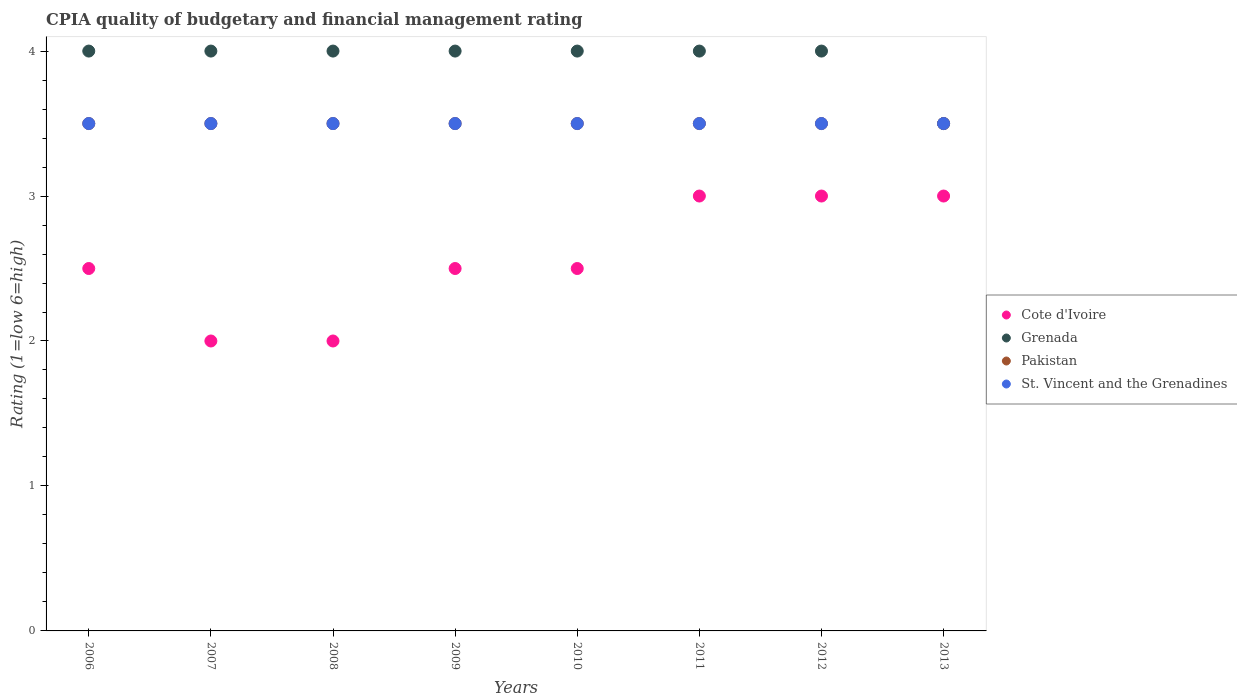What is the CPIA rating in Grenada in 2007?
Offer a very short reply. 4. In which year was the CPIA rating in St. Vincent and the Grenadines minimum?
Offer a very short reply. 2006. What is the total CPIA rating in Grenada in the graph?
Your response must be concise. 31.5. In the year 2006, what is the difference between the CPIA rating in St. Vincent and the Grenadines and CPIA rating in Pakistan?
Make the answer very short. 0. What is the ratio of the CPIA rating in Pakistan in 2008 to that in 2012?
Your response must be concise. 1. Is the CPIA rating in Grenada in 2006 less than that in 2007?
Ensure brevity in your answer.  No. What is the difference between the highest and the lowest CPIA rating in Grenada?
Give a very brief answer. 0.5. In how many years, is the CPIA rating in Cote d'Ivoire greater than the average CPIA rating in Cote d'Ivoire taken over all years?
Provide a succinct answer. 3. Is it the case that in every year, the sum of the CPIA rating in Cote d'Ivoire and CPIA rating in St. Vincent and the Grenadines  is greater than the sum of CPIA rating in Grenada and CPIA rating in Pakistan?
Provide a succinct answer. No. Is it the case that in every year, the sum of the CPIA rating in Grenada and CPIA rating in Cote d'Ivoire  is greater than the CPIA rating in St. Vincent and the Grenadines?
Your answer should be very brief. Yes. Does the CPIA rating in St. Vincent and the Grenadines monotonically increase over the years?
Your response must be concise. No. Is the CPIA rating in Pakistan strictly greater than the CPIA rating in St. Vincent and the Grenadines over the years?
Offer a very short reply. No. Is the CPIA rating in Grenada strictly less than the CPIA rating in Pakistan over the years?
Ensure brevity in your answer.  No. What is the difference between two consecutive major ticks on the Y-axis?
Provide a succinct answer. 1. Does the graph contain any zero values?
Offer a terse response. No. Does the graph contain grids?
Provide a short and direct response. No. How are the legend labels stacked?
Keep it short and to the point. Vertical. What is the title of the graph?
Your response must be concise. CPIA quality of budgetary and financial management rating. Does "Pacific island small states" appear as one of the legend labels in the graph?
Keep it short and to the point. No. What is the Rating (1=low 6=high) of Pakistan in 2006?
Your answer should be compact. 3.5. What is the Rating (1=low 6=high) in St. Vincent and the Grenadines in 2006?
Ensure brevity in your answer.  3.5. What is the Rating (1=low 6=high) in Grenada in 2007?
Keep it short and to the point. 4. What is the Rating (1=low 6=high) of St. Vincent and the Grenadines in 2007?
Make the answer very short. 3.5. What is the Rating (1=low 6=high) of Cote d'Ivoire in 2008?
Offer a terse response. 2. What is the Rating (1=low 6=high) in Grenada in 2008?
Give a very brief answer. 4. What is the Rating (1=low 6=high) of St. Vincent and the Grenadines in 2008?
Your answer should be very brief. 3.5. What is the Rating (1=low 6=high) in Pakistan in 2009?
Your answer should be compact. 3.5. What is the Rating (1=low 6=high) in St. Vincent and the Grenadines in 2009?
Give a very brief answer. 3.5. What is the Rating (1=low 6=high) of St. Vincent and the Grenadines in 2010?
Provide a succinct answer. 3.5. What is the Rating (1=low 6=high) in Grenada in 2011?
Your answer should be compact. 4. What is the Rating (1=low 6=high) in Pakistan in 2011?
Give a very brief answer. 3.5. What is the Rating (1=low 6=high) in Pakistan in 2012?
Make the answer very short. 3.5. What is the Rating (1=low 6=high) in Cote d'Ivoire in 2013?
Offer a terse response. 3. What is the Rating (1=low 6=high) in Grenada in 2013?
Give a very brief answer. 3.5. What is the Rating (1=low 6=high) of Pakistan in 2013?
Provide a short and direct response. 3.5. Across all years, what is the maximum Rating (1=low 6=high) of Cote d'Ivoire?
Offer a terse response. 3. Across all years, what is the maximum Rating (1=low 6=high) in Grenada?
Make the answer very short. 4. Across all years, what is the maximum Rating (1=low 6=high) of Pakistan?
Give a very brief answer. 3.5. Across all years, what is the maximum Rating (1=low 6=high) in St. Vincent and the Grenadines?
Your answer should be compact. 3.5. Across all years, what is the minimum Rating (1=low 6=high) of Grenada?
Offer a terse response. 3.5. Across all years, what is the minimum Rating (1=low 6=high) of Pakistan?
Your response must be concise. 3.5. Across all years, what is the minimum Rating (1=low 6=high) in St. Vincent and the Grenadines?
Provide a short and direct response. 3.5. What is the total Rating (1=low 6=high) of Grenada in the graph?
Offer a terse response. 31.5. What is the total Rating (1=low 6=high) in Pakistan in the graph?
Make the answer very short. 28. What is the difference between the Rating (1=low 6=high) of Grenada in 2006 and that in 2007?
Provide a short and direct response. 0. What is the difference between the Rating (1=low 6=high) in Pakistan in 2006 and that in 2007?
Provide a short and direct response. 0. What is the difference between the Rating (1=low 6=high) of Cote d'Ivoire in 2006 and that in 2008?
Keep it short and to the point. 0.5. What is the difference between the Rating (1=low 6=high) in St. Vincent and the Grenadines in 2006 and that in 2008?
Make the answer very short. 0. What is the difference between the Rating (1=low 6=high) in Cote d'Ivoire in 2006 and that in 2010?
Your answer should be compact. 0. What is the difference between the Rating (1=low 6=high) of Grenada in 2006 and that in 2010?
Your answer should be compact. 0. What is the difference between the Rating (1=low 6=high) of Grenada in 2006 and that in 2011?
Offer a very short reply. 0. What is the difference between the Rating (1=low 6=high) in Cote d'Ivoire in 2006 and that in 2012?
Offer a very short reply. -0.5. What is the difference between the Rating (1=low 6=high) of Cote d'Ivoire in 2006 and that in 2013?
Keep it short and to the point. -0.5. What is the difference between the Rating (1=low 6=high) in Pakistan in 2006 and that in 2013?
Keep it short and to the point. 0. What is the difference between the Rating (1=low 6=high) of St. Vincent and the Grenadines in 2006 and that in 2013?
Your answer should be compact. 0. What is the difference between the Rating (1=low 6=high) of Grenada in 2007 and that in 2008?
Your answer should be compact. 0. What is the difference between the Rating (1=low 6=high) in Pakistan in 2007 and that in 2008?
Offer a terse response. 0. What is the difference between the Rating (1=low 6=high) of St. Vincent and the Grenadines in 2007 and that in 2008?
Offer a very short reply. 0. What is the difference between the Rating (1=low 6=high) in Grenada in 2007 and that in 2009?
Your answer should be compact. 0. What is the difference between the Rating (1=low 6=high) in Pakistan in 2007 and that in 2009?
Your answer should be very brief. 0. What is the difference between the Rating (1=low 6=high) in St. Vincent and the Grenadines in 2007 and that in 2009?
Your answer should be compact. 0. What is the difference between the Rating (1=low 6=high) in Cote d'Ivoire in 2007 and that in 2010?
Offer a terse response. -0.5. What is the difference between the Rating (1=low 6=high) in Grenada in 2007 and that in 2010?
Provide a succinct answer. 0. What is the difference between the Rating (1=low 6=high) in St. Vincent and the Grenadines in 2007 and that in 2010?
Keep it short and to the point. 0. What is the difference between the Rating (1=low 6=high) in Cote d'Ivoire in 2007 and that in 2011?
Keep it short and to the point. -1. What is the difference between the Rating (1=low 6=high) of St. Vincent and the Grenadines in 2007 and that in 2011?
Give a very brief answer. 0. What is the difference between the Rating (1=low 6=high) in Grenada in 2007 and that in 2012?
Give a very brief answer. 0. What is the difference between the Rating (1=low 6=high) of Cote d'Ivoire in 2007 and that in 2013?
Provide a short and direct response. -1. What is the difference between the Rating (1=low 6=high) of Grenada in 2007 and that in 2013?
Provide a succinct answer. 0.5. What is the difference between the Rating (1=low 6=high) in Pakistan in 2007 and that in 2013?
Provide a short and direct response. 0. What is the difference between the Rating (1=low 6=high) of St. Vincent and the Grenadines in 2007 and that in 2013?
Make the answer very short. 0. What is the difference between the Rating (1=low 6=high) in St. Vincent and the Grenadines in 2008 and that in 2009?
Your answer should be very brief. 0. What is the difference between the Rating (1=low 6=high) of Grenada in 2008 and that in 2010?
Ensure brevity in your answer.  0. What is the difference between the Rating (1=low 6=high) in Pakistan in 2008 and that in 2010?
Your answer should be compact. 0. What is the difference between the Rating (1=low 6=high) in St. Vincent and the Grenadines in 2008 and that in 2010?
Your response must be concise. 0. What is the difference between the Rating (1=low 6=high) of Cote d'Ivoire in 2008 and that in 2011?
Offer a terse response. -1. What is the difference between the Rating (1=low 6=high) of Grenada in 2008 and that in 2011?
Provide a short and direct response. 0. What is the difference between the Rating (1=low 6=high) in Pakistan in 2008 and that in 2011?
Your answer should be very brief. 0. What is the difference between the Rating (1=low 6=high) of St. Vincent and the Grenadines in 2008 and that in 2011?
Your answer should be very brief. 0. What is the difference between the Rating (1=low 6=high) of Cote d'Ivoire in 2008 and that in 2013?
Offer a terse response. -1. What is the difference between the Rating (1=low 6=high) of Grenada in 2008 and that in 2013?
Provide a short and direct response. 0.5. What is the difference between the Rating (1=low 6=high) of St. Vincent and the Grenadines in 2008 and that in 2013?
Your answer should be compact. 0. What is the difference between the Rating (1=low 6=high) of Cote d'Ivoire in 2009 and that in 2010?
Keep it short and to the point. 0. What is the difference between the Rating (1=low 6=high) of St. Vincent and the Grenadines in 2009 and that in 2010?
Your answer should be compact. 0. What is the difference between the Rating (1=low 6=high) of Cote d'Ivoire in 2009 and that in 2011?
Offer a terse response. -0.5. What is the difference between the Rating (1=low 6=high) of Grenada in 2009 and that in 2011?
Your response must be concise. 0. What is the difference between the Rating (1=low 6=high) in Pakistan in 2009 and that in 2011?
Ensure brevity in your answer.  0. What is the difference between the Rating (1=low 6=high) in Cote d'Ivoire in 2009 and that in 2012?
Keep it short and to the point. -0.5. What is the difference between the Rating (1=low 6=high) of Grenada in 2009 and that in 2012?
Keep it short and to the point. 0. What is the difference between the Rating (1=low 6=high) in St. Vincent and the Grenadines in 2009 and that in 2012?
Keep it short and to the point. 0. What is the difference between the Rating (1=low 6=high) of Cote d'Ivoire in 2009 and that in 2013?
Give a very brief answer. -0.5. What is the difference between the Rating (1=low 6=high) in Grenada in 2009 and that in 2013?
Offer a very short reply. 0.5. What is the difference between the Rating (1=low 6=high) of Pakistan in 2009 and that in 2013?
Provide a short and direct response. 0. What is the difference between the Rating (1=low 6=high) of Pakistan in 2010 and that in 2011?
Your response must be concise. 0. What is the difference between the Rating (1=low 6=high) in Grenada in 2010 and that in 2012?
Give a very brief answer. 0. What is the difference between the Rating (1=low 6=high) in Grenada in 2010 and that in 2013?
Provide a succinct answer. 0.5. What is the difference between the Rating (1=low 6=high) in St. Vincent and the Grenadines in 2010 and that in 2013?
Provide a succinct answer. 0. What is the difference between the Rating (1=low 6=high) in Grenada in 2011 and that in 2012?
Your answer should be compact. 0. What is the difference between the Rating (1=low 6=high) of Cote d'Ivoire in 2011 and that in 2013?
Provide a succinct answer. 0. What is the difference between the Rating (1=low 6=high) in Grenada in 2011 and that in 2013?
Offer a very short reply. 0.5. What is the difference between the Rating (1=low 6=high) in Pakistan in 2011 and that in 2013?
Your response must be concise. 0. What is the difference between the Rating (1=low 6=high) of St. Vincent and the Grenadines in 2011 and that in 2013?
Give a very brief answer. 0. What is the difference between the Rating (1=low 6=high) of Cote d'Ivoire in 2012 and that in 2013?
Provide a succinct answer. 0. What is the difference between the Rating (1=low 6=high) of St. Vincent and the Grenadines in 2012 and that in 2013?
Your answer should be very brief. 0. What is the difference between the Rating (1=low 6=high) of Cote d'Ivoire in 2006 and the Rating (1=low 6=high) of Grenada in 2007?
Your answer should be compact. -1.5. What is the difference between the Rating (1=low 6=high) of Cote d'Ivoire in 2006 and the Rating (1=low 6=high) of Pakistan in 2007?
Provide a short and direct response. -1. What is the difference between the Rating (1=low 6=high) of Cote d'Ivoire in 2006 and the Rating (1=low 6=high) of St. Vincent and the Grenadines in 2007?
Ensure brevity in your answer.  -1. What is the difference between the Rating (1=low 6=high) of Grenada in 2006 and the Rating (1=low 6=high) of Pakistan in 2007?
Make the answer very short. 0.5. What is the difference between the Rating (1=low 6=high) of Grenada in 2006 and the Rating (1=low 6=high) of St. Vincent and the Grenadines in 2007?
Keep it short and to the point. 0.5. What is the difference between the Rating (1=low 6=high) in Cote d'Ivoire in 2006 and the Rating (1=low 6=high) in Pakistan in 2008?
Keep it short and to the point. -1. What is the difference between the Rating (1=low 6=high) in Pakistan in 2006 and the Rating (1=low 6=high) in St. Vincent and the Grenadines in 2008?
Make the answer very short. 0. What is the difference between the Rating (1=low 6=high) of Cote d'Ivoire in 2006 and the Rating (1=low 6=high) of Grenada in 2009?
Your answer should be very brief. -1.5. What is the difference between the Rating (1=low 6=high) in Cote d'Ivoire in 2006 and the Rating (1=low 6=high) in Pakistan in 2009?
Keep it short and to the point. -1. What is the difference between the Rating (1=low 6=high) of Cote d'Ivoire in 2006 and the Rating (1=low 6=high) of St. Vincent and the Grenadines in 2009?
Make the answer very short. -1. What is the difference between the Rating (1=low 6=high) of Grenada in 2006 and the Rating (1=low 6=high) of Pakistan in 2009?
Provide a succinct answer. 0.5. What is the difference between the Rating (1=low 6=high) in Grenada in 2006 and the Rating (1=low 6=high) in St. Vincent and the Grenadines in 2009?
Your answer should be compact. 0.5. What is the difference between the Rating (1=low 6=high) of Cote d'Ivoire in 2006 and the Rating (1=low 6=high) of St. Vincent and the Grenadines in 2010?
Provide a succinct answer. -1. What is the difference between the Rating (1=low 6=high) in Grenada in 2006 and the Rating (1=low 6=high) in Pakistan in 2011?
Offer a terse response. 0.5. What is the difference between the Rating (1=low 6=high) in Cote d'Ivoire in 2006 and the Rating (1=low 6=high) in Grenada in 2012?
Your response must be concise. -1.5. What is the difference between the Rating (1=low 6=high) in Grenada in 2006 and the Rating (1=low 6=high) in Pakistan in 2012?
Offer a terse response. 0.5. What is the difference between the Rating (1=low 6=high) in Grenada in 2006 and the Rating (1=low 6=high) in St. Vincent and the Grenadines in 2012?
Offer a terse response. 0.5. What is the difference between the Rating (1=low 6=high) of Pakistan in 2006 and the Rating (1=low 6=high) of St. Vincent and the Grenadines in 2012?
Provide a short and direct response. 0. What is the difference between the Rating (1=low 6=high) of Cote d'Ivoire in 2006 and the Rating (1=low 6=high) of St. Vincent and the Grenadines in 2013?
Make the answer very short. -1. What is the difference between the Rating (1=low 6=high) of Grenada in 2006 and the Rating (1=low 6=high) of St. Vincent and the Grenadines in 2013?
Offer a terse response. 0.5. What is the difference between the Rating (1=low 6=high) in Cote d'Ivoire in 2007 and the Rating (1=low 6=high) in Grenada in 2008?
Give a very brief answer. -2. What is the difference between the Rating (1=low 6=high) of Grenada in 2007 and the Rating (1=low 6=high) of St. Vincent and the Grenadines in 2008?
Provide a succinct answer. 0.5. What is the difference between the Rating (1=low 6=high) in Pakistan in 2007 and the Rating (1=low 6=high) in St. Vincent and the Grenadines in 2008?
Offer a terse response. 0. What is the difference between the Rating (1=low 6=high) of Cote d'Ivoire in 2007 and the Rating (1=low 6=high) of Grenada in 2009?
Keep it short and to the point. -2. What is the difference between the Rating (1=low 6=high) in Cote d'Ivoire in 2007 and the Rating (1=low 6=high) in Pakistan in 2009?
Offer a terse response. -1.5. What is the difference between the Rating (1=low 6=high) of Cote d'Ivoire in 2007 and the Rating (1=low 6=high) of St. Vincent and the Grenadines in 2009?
Ensure brevity in your answer.  -1.5. What is the difference between the Rating (1=low 6=high) in Grenada in 2007 and the Rating (1=low 6=high) in St. Vincent and the Grenadines in 2009?
Give a very brief answer. 0.5. What is the difference between the Rating (1=low 6=high) in Pakistan in 2007 and the Rating (1=low 6=high) in St. Vincent and the Grenadines in 2009?
Offer a very short reply. 0. What is the difference between the Rating (1=low 6=high) of Cote d'Ivoire in 2007 and the Rating (1=low 6=high) of Pakistan in 2010?
Your answer should be compact. -1.5. What is the difference between the Rating (1=low 6=high) in Cote d'Ivoire in 2007 and the Rating (1=low 6=high) in St. Vincent and the Grenadines in 2010?
Provide a succinct answer. -1.5. What is the difference between the Rating (1=low 6=high) in Grenada in 2007 and the Rating (1=low 6=high) in Pakistan in 2010?
Offer a terse response. 0.5. What is the difference between the Rating (1=low 6=high) in Grenada in 2007 and the Rating (1=low 6=high) in St. Vincent and the Grenadines in 2010?
Make the answer very short. 0.5. What is the difference between the Rating (1=low 6=high) of Cote d'Ivoire in 2007 and the Rating (1=low 6=high) of Grenada in 2011?
Ensure brevity in your answer.  -2. What is the difference between the Rating (1=low 6=high) in Cote d'Ivoire in 2007 and the Rating (1=low 6=high) in Pakistan in 2011?
Give a very brief answer. -1.5. What is the difference between the Rating (1=low 6=high) in Cote d'Ivoire in 2007 and the Rating (1=low 6=high) in St. Vincent and the Grenadines in 2011?
Your answer should be very brief. -1.5. What is the difference between the Rating (1=low 6=high) in Grenada in 2007 and the Rating (1=low 6=high) in St. Vincent and the Grenadines in 2011?
Give a very brief answer. 0.5. What is the difference between the Rating (1=low 6=high) of Grenada in 2007 and the Rating (1=low 6=high) of St. Vincent and the Grenadines in 2012?
Offer a very short reply. 0.5. What is the difference between the Rating (1=low 6=high) of Cote d'Ivoire in 2007 and the Rating (1=low 6=high) of St. Vincent and the Grenadines in 2013?
Keep it short and to the point. -1.5. What is the difference between the Rating (1=low 6=high) in Grenada in 2007 and the Rating (1=low 6=high) in Pakistan in 2013?
Your response must be concise. 0.5. What is the difference between the Rating (1=low 6=high) of Pakistan in 2007 and the Rating (1=low 6=high) of St. Vincent and the Grenadines in 2013?
Your answer should be compact. 0. What is the difference between the Rating (1=low 6=high) of Grenada in 2008 and the Rating (1=low 6=high) of Pakistan in 2009?
Make the answer very short. 0.5. What is the difference between the Rating (1=low 6=high) of Grenada in 2008 and the Rating (1=low 6=high) of St. Vincent and the Grenadines in 2009?
Provide a succinct answer. 0.5. What is the difference between the Rating (1=low 6=high) of Pakistan in 2008 and the Rating (1=low 6=high) of St. Vincent and the Grenadines in 2009?
Make the answer very short. 0. What is the difference between the Rating (1=low 6=high) of Cote d'Ivoire in 2008 and the Rating (1=low 6=high) of Grenada in 2010?
Your answer should be compact. -2. What is the difference between the Rating (1=low 6=high) of Cote d'Ivoire in 2008 and the Rating (1=low 6=high) of Pakistan in 2010?
Keep it short and to the point. -1.5. What is the difference between the Rating (1=low 6=high) of Cote d'Ivoire in 2008 and the Rating (1=low 6=high) of St. Vincent and the Grenadines in 2010?
Provide a succinct answer. -1.5. What is the difference between the Rating (1=low 6=high) of Grenada in 2008 and the Rating (1=low 6=high) of Pakistan in 2010?
Your response must be concise. 0.5. What is the difference between the Rating (1=low 6=high) of Pakistan in 2008 and the Rating (1=low 6=high) of St. Vincent and the Grenadines in 2010?
Your response must be concise. 0. What is the difference between the Rating (1=low 6=high) in Cote d'Ivoire in 2008 and the Rating (1=low 6=high) in Grenada in 2011?
Your answer should be very brief. -2. What is the difference between the Rating (1=low 6=high) in Cote d'Ivoire in 2008 and the Rating (1=low 6=high) in Pakistan in 2011?
Give a very brief answer. -1.5. What is the difference between the Rating (1=low 6=high) of Cote d'Ivoire in 2008 and the Rating (1=low 6=high) of St. Vincent and the Grenadines in 2011?
Offer a terse response. -1.5. What is the difference between the Rating (1=low 6=high) in Grenada in 2008 and the Rating (1=low 6=high) in Pakistan in 2011?
Offer a terse response. 0.5. What is the difference between the Rating (1=low 6=high) in Grenada in 2008 and the Rating (1=low 6=high) in St. Vincent and the Grenadines in 2011?
Provide a short and direct response. 0.5. What is the difference between the Rating (1=low 6=high) in Cote d'Ivoire in 2008 and the Rating (1=low 6=high) in Grenada in 2012?
Ensure brevity in your answer.  -2. What is the difference between the Rating (1=low 6=high) of Cote d'Ivoire in 2008 and the Rating (1=low 6=high) of St. Vincent and the Grenadines in 2012?
Provide a short and direct response. -1.5. What is the difference between the Rating (1=low 6=high) of Grenada in 2008 and the Rating (1=low 6=high) of St. Vincent and the Grenadines in 2012?
Your answer should be very brief. 0.5. What is the difference between the Rating (1=low 6=high) in Grenada in 2008 and the Rating (1=low 6=high) in Pakistan in 2013?
Provide a succinct answer. 0.5. What is the difference between the Rating (1=low 6=high) of Pakistan in 2008 and the Rating (1=low 6=high) of St. Vincent and the Grenadines in 2013?
Make the answer very short. 0. What is the difference between the Rating (1=low 6=high) in Cote d'Ivoire in 2009 and the Rating (1=low 6=high) in Pakistan in 2010?
Provide a succinct answer. -1. What is the difference between the Rating (1=low 6=high) in Cote d'Ivoire in 2009 and the Rating (1=low 6=high) in St. Vincent and the Grenadines in 2010?
Offer a very short reply. -1. What is the difference between the Rating (1=low 6=high) in Grenada in 2009 and the Rating (1=low 6=high) in Pakistan in 2010?
Your answer should be compact. 0.5. What is the difference between the Rating (1=low 6=high) in Grenada in 2009 and the Rating (1=low 6=high) in St. Vincent and the Grenadines in 2010?
Ensure brevity in your answer.  0.5. What is the difference between the Rating (1=low 6=high) in Pakistan in 2009 and the Rating (1=low 6=high) in St. Vincent and the Grenadines in 2010?
Offer a very short reply. 0. What is the difference between the Rating (1=low 6=high) of Cote d'Ivoire in 2009 and the Rating (1=low 6=high) of Pakistan in 2011?
Your answer should be compact. -1. What is the difference between the Rating (1=low 6=high) of Cote d'Ivoire in 2009 and the Rating (1=low 6=high) of St. Vincent and the Grenadines in 2011?
Provide a short and direct response. -1. What is the difference between the Rating (1=low 6=high) of Grenada in 2009 and the Rating (1=low 6=high) of Pakistan in 2011?
Offer a terse response. 0.5. What is the difference between the Rating (1=low 6=high) in Pakistan in 2009 and the Rating (1=low 6=high) in St. Vincent and the Grenadines in 2011?
Offer a very short reply. 0. What is the difference between the Rating (1=low 6=high) in Cote d'Ivoire in 2009 and the Rating (1=low 6=high) in Grenada in 2012?
Offer a very short reply. -1.5. What is the difference between the Rating (1=low 6=high) of Cote d'Ivoire in 2009 and the Rating (1=low 6=high) of St. Vincent and the Grenadines in 2012?
Give a very brief answer. -1. What is the difference between the Rating (1=low 6=high) of Grenada in 2009 and the Rating (1=low 6=high) of Pakistan in 2012?
Provide a short and direct response. 0.5. What is the difference between the Rating (1=low 6=high) of Cote d'Ivoire in 2009 and the Rating (1=low 6=high) of St. Vincent and the Grenadines in 2013?
Ensure brevity in your answer.  -1. What is the difference between the Rating (1=low 6=high) of Grenada in 2009 and the Rating (1=low 6=high) of Pakistan in 2013?
Give a very brief answer. 0.5. What is the difference between the Rating (1=low 6=high) of Pakistan in 2009 and the Rating (1=low 6=high) of St. Vincent and the Grenadines in 2013?
Your response must be concise. 0. What is the difference between the Rating (1=low 6=high) in Cote d'Ivoire in 2010 and the Rating (1=low 6=high) in Pakistan in 2011?
Ensure brevity in your answer.  -1. What is the difference between the Rating (1=low 6=high) in Pakistan in 2010 and the Rating (1=low 6=high) in St. Vincent and the Grenadines in 2011?
Provide a succinct answer. 0. What is the difference between the Rating (1=low 6=high) in Cote d'Ivoire in 2010 and the Rating (1=low 6=high) in Grenada in 2012?
Give a very brief answer. -1.5. What is the difference between the Rating (1=low 6=high) of Grenada in 2010 and the Rating (1=low 6=high) of Pakistan in 2012?
Your answer should be very brief. 0.5. What is the difference between the Rating (1=low 6=high) of Pakistan in 2010 and the Rating (1=low 6=high) of St. Vincent and the Grenadines in 2012?
Give a very brief answer. 0. What is the difference between the Rating (1=low 6=high) of Cote d'Ivoire in 2010 and the Rating (1=low 6=high) of Grenada in 2013?
Ensure brevity in your answer.  -1. What is the difference between the Rating (1=low 6=high) in Cote d'Ivoire in 2010 and the Rating (1=low 6=high) in Pakistan in 2013?
Ensure brevity in your answer.  -1. What is the difference between the Rating (1=low 6=high) in Cote d'Ivoire in 2010 and the Rating (1=low 6=high) in St. Vincent and the Grenadines in 2013?
Offer a very short reply. -1. What is the difference between the Rating (1=low 6=high) of Grenada in 2010 and the Rating (1=low 6=high) of Pakistan in 2013?
Give a very brief answer. 0.5. What is the difference between the Rating (1=low 6=high) of Cote d'Ivoire in 2011 and the Rating (1=low 6=high) of St. Vincent and the Grenadines in 2012?
Provide a short and direct response. -0.5. What is the difference between the Rating (1=low 6=high) in Grenada in 2011 and the Rating (1=low 6=high) in St. Vincent and the Grenadines in 2012?
Give a very brief answer. 0.5. What is the difference between the Rating (1=low 6=high) in Pakistan in 2011 and the Rating (1=low 6=high) in St. Vincent and the Grenadines in 2012?
Your answer should be very brief. 0. What is the difference between the Rating (1=low 6=high) in Grenada in 2011 and the Rating (1=low 6=high) in St. Vincent and the Grenadines in 2013?
Provide a short and direct response. 0.5. What is the difference between the Rating (1=low 6=high) in Pakistan in 2011 and the Rating (1=low 6=high) in St. Vincent and the Grenadines in 2013?
Your answer should be very brief. 0. What is the difference between the Rating (1=low 6=high) in Cote d'Ivoire in 2012 and the Rating (1=low 6=high) in Grenada in 2013?
Keep it short and to the point. -0.5. What is the difference between the Rating (1=low 6=high) in Cote d'Ivoire in 2012 and the Rating (1=low 6=high) in Pakistan in 2013?
Your answer should be compact. -0.5. What is the difference between the Rating (1=low 6=high) in Cote d'Ivoire in 2012 and the Rating (1=low 6=high) in St. Vincent and the Grenadines in 2013?
Give a very brief answer. -0.5. What is the difference between the Rating (1=low 6=high) of Grenada in 2012 and the Rating (1=low 6=high) of Pakistan in 2013?
Keep it short and to the point. 0.5. What is the difference between the Rating (1=low 6=high) of Grenada in 2012 and the Rating (1=low 6=high) of St. Vincent and the Grenadines in 2013?
Your response must be concise. 0.5. What is the average Rating (1=low 6=high) in Cote d'Ivoire per year?
Provide a succinct answer. 2.56. What is the average Rating (1=low 6=high) of Grenada per year?
Your answer should be very brief. 3.94. What is the average Rating (1=low 6=high) of St. Vincent and the Grenadines per year?
Keep it short and to the point. 3.5. In the year 2006, what is the difference between the Rating (1=low 6=high) of Cote d'Ivoire and Rating (1=low 6=high) of Grenada?
Provide a succinct answer. -1.5. In the year 2006, what is the difference between the Rating (1=low 6=high) in Cote d'Ivoire and Rating (1=low 6=high) in St. Vincent and the Grenadines?
Provide a succinct answer. -1. In the year 2006, what is the difference between the Rating (1=low 6=high) in Grenada and Rating (1=low 6=high) in Pakistan?
Your response must be concise. 0.5. In the year 2006, what is the difference between the Rating (1=low 6=high) of Pakistan and Rating (1=low 6=high) of St. Vincent and the Grenadines?
Offer a terse response. 0. In the year 2007, what is the difference between the Rating (1=low 6=high) of Cote d'Ivoire and Rating (1=low 6=high) of Grenada?
Provide a short and direct response. -2. In the year 2007, what is the difference between the Rating (1=low 6=high) of Cote d'Ivoire and Rating (1=low 6=high) of Pakistan?
Keep it short and to the point. -1.5. In the year 2007, what is the difference between the Rating (1=low 6=high) of Cote d'Ivoire and Rating (1=low 6=high) of St. Vincent and the Grenadines?
Offer a terse response. -1.5. In the year 2007, what is the difference between the Rating (1=low 6=high) in Grenada and Rating (1=low 6=high) in St. Vincent and the Grenadines?
Provide a succinct answer. 0.5. In the year 2008, what is the difference between the Rating (1=low 6=high) in Grenada and Rating (1=low 6=high) in Pakistan?
Your answer should be compact. 0.5. In the year 2008, what is the difference between the Rating (1=low 6=high) in Grenada and Rating (1=low 6=high) in St. Vincent and the Grenadines?
Ensure brevity in your answer.  0.5. In the year 2008, what is the difference between the Rating (1=low 6=high) of Pakistan and Rating (1=low 6=high) of St. Vincent and the Grenadines?
Give a very brief answer. 0. In the year 2009, what is the difference between the Rating (1=low 6=high) in Cote d'Ivoire and Rating (1=low 6=high) in Pakistan?
Ensure brevity in your answer.  -1. In the year 2009, what is the difference between the Rating (1=low 6=high) in Grenada and Rating (1=low 6=high) in Pakistan?
Offer a terse response. 0.5. In the year 2009, what is the difference between the Rating (1=low 6=high) in Grenada and Rating (1=low 6=high) in St. Vincent and the Grenadines?
Offer a very short reply. 0.5. In the year 2010, what is the difference between the Rating (1=low 6=high) of Cote d'Ivoire and Rating (1=low 6=high) of Grenada?
Give a very brief answer. -1.5. In the year 2010, what is the difference between the Rating (1=low 6=high) of Grenada and Rating (1=low 6=high) of Pakistan?
Your answer should be very brief. 0.5. In the year 2010, what is the difference between the Rating (1=low 6=high) in Grenada and Rating (1=low 6=high) in St. Vincent and the Grenadines?
Offer a very short reply. 0.5. In the year 2010, what is the difference between the Rating (1=low 6=high) in Pakistan and Rating (1=low 6=high) in St. Vincent and the Grenadines?
Your answer should be very brief. 0. In the year 2011, what is the difference between the Rating (1=low 6=high) of Cote d'Ivoire and Rating (1=low 6=high) of Grenada?
Offer a very short reply. -1. In the year 2011, what is the difference between the Rating (1=low 6=high) in Cote d'Ivoire and Rating (1=low 6=high) in St. Vincent and the Grenadines?
Offer a very short reply. -0.5. In the year 2011, what is the difference between the Rating (1=low 6=high) in Pakistan and Rating (1=low 6=high) in St. Vincent and the Grenadines?
Give a very brief answer. 0. In the year 2012, what is the difference between the Rating (1=low 6=high) in Cote d'Ivoire and Rating (1=low 6=high) in Grenada?
Your answer should be very brief. -1. In the year 2012, what is the difference between the Rating (1=low 6=high) of Cote d'Ivoire and Rating (1=low 6=high) of Pakistan?
Make the answer very short. -0.5. In the year 2012, what is the difference between the Rating (1=low 6=high) of Grenada and Rating (1=low 6=high) of Pakistan?
Offer a very short reply. 0.5. In the year 2013, what is the difference between the Rating (1=low 6=high) in Cote d'Ivoire and Rating (1=low 6=high) in St. Vincent and the Grenadines?
Your answer should be compact. -0.5. In the year 2013, what is the difference between the Rating (1=low 6=high) of Grenada and Rating (1=low 6=high) of St. Vincent and the Grenadines?
Your answer should be compact. 0. What is the ratio of the Rating (1=low 6=high) in Cote d'Ivoire in 2006 to that in 2008?
Provide a succinct answer. 1.25. What is the ratio of the Rating (1=low 6=high) of Grenada in 2006 to that in 2008?
Provide a short and direct response. 1. What is the ratio of the Rating (1=low 6=high) of Cote d'Ivoire in 2006 to that in 2009?
Offer a very short reply. 1. What is the ratio of the Rating (1=low 6=high) of Grenada in 2006 to that in 2009?
Your answer should be very brief. 1. What is the ratio of the Rating (1=low 6=high) in Pakistan in 2006 to that in 2009?
Offer a very short reply. 1. What is the ratio of the Rating (1=low 6=high) in St. Vincent and the Grenadines in 2006 to that in 2009?
Make the answer very short. 1. What is the ratio of the Rating (1=low 6=high) in Cote d'Ivoire in 2006 to that in 2010?
Offer a very short reply. 1. What is the ratio of the Rating (1=low 6=high) of Grenada in 2006 to that in 2010?
Provide a short and direct response. 1. What is the ratio of the Rating (1=low 6=high) in Pakistan in 2006 to that in 2010?
Ensure brevity in your answer.  1. What is the ratio of the Rating (1=low 6=high) of St. Vincent and the Grenadines in 2006 to that in 2010?
Offer a terse response. 1. What is the ratio of the Rating (1=low 6=high) in Pakistan in 2006 to that in 2011?
Provide a short and direct response. 1. What is the ratio of the Rating (1=low 6=high) in St. Vincent and the Grenadines in 2006 to that in 2011?
Ensure brevity in your answer.  1. What is the ratio of the Rating (1=low 6=high) in Cote d'Ivoire in 2006 to that in 2012?
Offer a terse response. 0.83. What is the ratio of the Rating (1=low 6=high) of Cote d'Ivoire in 2006 to that in 2013?
Ensure brevity in your answer.  0.83. What is the ratio of the Rating (1=low 6=high) in Grenada in 2006 to that in 2013?
Keep it short and to the point. 1.14. What is the ratio of the Rating (1=low 6=high) of Pakistan in 2006 to that in 2013?
Provide a short and direct response. 1. What is the ratio of the Rating (1=low 6=high) of Cote d'Ivoire in 2007 to that in 2008?
Give a very brief answer. 1. What is the ratio of the Rating (1=low 6=high) in Grenada in 2007 to that in 2008?
Give a very brief answer. 1. What is the ratio of the Rating (1=low 6=high) in Grenada in 2007 to that in 2009?
Provide a succinct answer. 1. What is the ratio of the Rating (1=low 6=high) of Pakistan in 2007 to that in 2009?
Offer a very short reply. 1. What is the ratio of the Rating (1=low 6=high) in Cote d'Ivoire in 2007 to that in 2010?
Make the answer very short. 0.8. What is the ratio of the Rating (1=low 6=high) in St. Vincent and the Grenadines in 2007 to that in 2010?
Make the answer very short. 1. What is the ratio of the Rating (1=low 6=high) of St. Vincent and the Grenadines in 2007 to that in 2011?
Offer a terse response. 1. What is the ratio of the Rating (1=low 6=high) of Cote d'Ivoire in 2007 to that in 2013?
Your answer should be compact. 0.67. What is the ratio of the Rating (1=low 6=high) in Grenada in 2007 to that in 2013?
Your answer should be compact. 1.14. What is the ratio of the Rating (1=low 6=high) in St. Vincent and the Grenadines in 2007 to that in 2013?
Give a very brief answer. 1. What is the ratio of the Rating (1=low 6=high) in Grenada in 2008 to that in 2009?
Offer a terse response. 1. What is the ratio of the Rating (1=low 6=high) in St. Vincent and the Grenadines in 2008 to that in 2009?
Provide a succinct answer. 1. What is the ratio of the Rating (1=low 6=high) in Cote d'Ivoire in 2008 to that in 2010?
Your answer should be compact. 0.8. What is the ratio of the Rating (1=low 6=high) of Pakistan in 2008 to that in 2010?
Keep it short and to the point. 1. What is the ratio of the Rating (1=low 6=high) of Grenada in 2008 to that in 2011?
Give a very brief answer. 1. What is the ratio of the Rating (1=low 6=high) in Pakistan in 2008 to that in 2011?
Give a very brief answer. 1. What is the ratio of the Rating (1=low 6=high) in St. Vincent and the Grenadines in 2008 to that in 2011?
Offer a very short reply. 1. What is the ratio of the Rating (1=low 6=high) in Pakistan in 2008 to that in 2013?
Your response must be concise. 1. What is the ratio of the Rating (1=low 6=high) of St. Vincent and the Grenadines in 2008 to that in 2013?
Give a very brief answer. 1. What is the ratio of the Rating (1=low 6=high) of Grenada in 2009 to that in 2010?
Your response must be concise. 1. What is the ratio of the Rating (1=low 6=high) in Pakistan in 2009 to that in 2010?
Provide a short and direct response. 1. What is the ratio of the Rating (1=low 6=high) in Cote d'Ivoire in 2009 to that in 2012?
Your response must be concise. 0.83. What is the ratio of the Rating (1=low 6=high) in Grenada in 2009 to that in 2012?
Provide a short and direct response. 1. What is the ratio of the Rating (1=low 6=high) in St. Vincent and the Grenadines in 2009 to that in 2012?
Give a very brief answer. 1. What is the ratio of the Rating (1=low 6=high) in Cote d'Ivoire in 2009 to that in 2013?
Offer a very short reply. 0.83. What is the ratio of the Rating (1=low 6=high) in Grenada in 2009 to that in 2013?
Ensure brevity in your answer.  1.14. What is the ratio of the Rating (1=low 6=high) in Cote d'Ivoire in 2010 to that in 2011?
Ensure brevity in your answer.  0.83. What is the ratio of the Rating (1=low 6=high) in Grenada in 2010 to that in 2011?
Offer a very short reply. 1. What is the ratio of the Rating (1=low 6=high) in Pakistan in 2010 to that in 2011?
Your response must be concise. 1. What is the ratio of the Rating (1=low 6=high) in St. Vincent and the Grenadines in 2010 to that in 2011?
Your answer should be very brief. 1. What is the ratio of the Rating (1=low 6=high) in Grenada in 2010 to that in 2012?
Make the answer very short. 1. What is the ratio of the Rating (1=low 6=high) of Pakistan in 2010 to that in 2012?
Your answer should be compact. 1. What is the ratio of the Rating (1=low 6=high) in St. Vincent and the Grenadines in 2010 to that in 2012?
Provide a short and direct response. 1. What is the ratio of the Rating (1=low 6=high) in Grenada in 2010 to that in 2013?
Ensure brevity in your answer.  1.14. What is the ratio of the Rating (1=low 6=high) of St. Vincent and the Grenadines in 2010 to that in 2013?
Offer a very short reply. 1. What is the ratio of the Rating (1=low 6=high) in Cote d'Ivoire in 2011 to that in 2013?
Offer a very short reply. 1. What is the ratio of the Rating (1=low 6=high) in Grenada in 2011 to that in 2013?
Provide a succinct answer. 1.14. What is the ratio of the Rating (1=low 6=high) of Pakistan in 2011 to that in 2013?
Provide a succinct answer. 1. What is the ratio of the Rating (1=low 6=high) in St. Vincent and the Grenadines in 2011 to that in 2013?
Your response must be concise. 1. What is the ratio of the Rating (1=low 6=high) of Cote d'Ivoire in 2012 to that in 2013?
Offer a very short reply. 1. What is the ratio of the Rating (1=low 6=high) of Grenada in 2012 to that in 2013?
Make the answer very short. 1.14. What is the ratio of the Rating (1=low 6=high) of Pakistan in 2012 to that in 2013?
Make the answer very short. 1. What is the difference between the highest and the second highest Rating (1=low 6=high) of Cote d'Ivoire?
Offer a very short reply. 0. What is the difference between the highest and the second highest Rating (1=low 6=high) in Pakistan?
Provide a short and direct response. 0. What is the difference between the highest and the lowest Rating (1=low 6=high) of Grenada?
Keep it short and to the point. 0.5. What is the difference between the highest and the lowest Rating (1=low 6=high) in Pakistan?
Your answer should be compact. 0. 